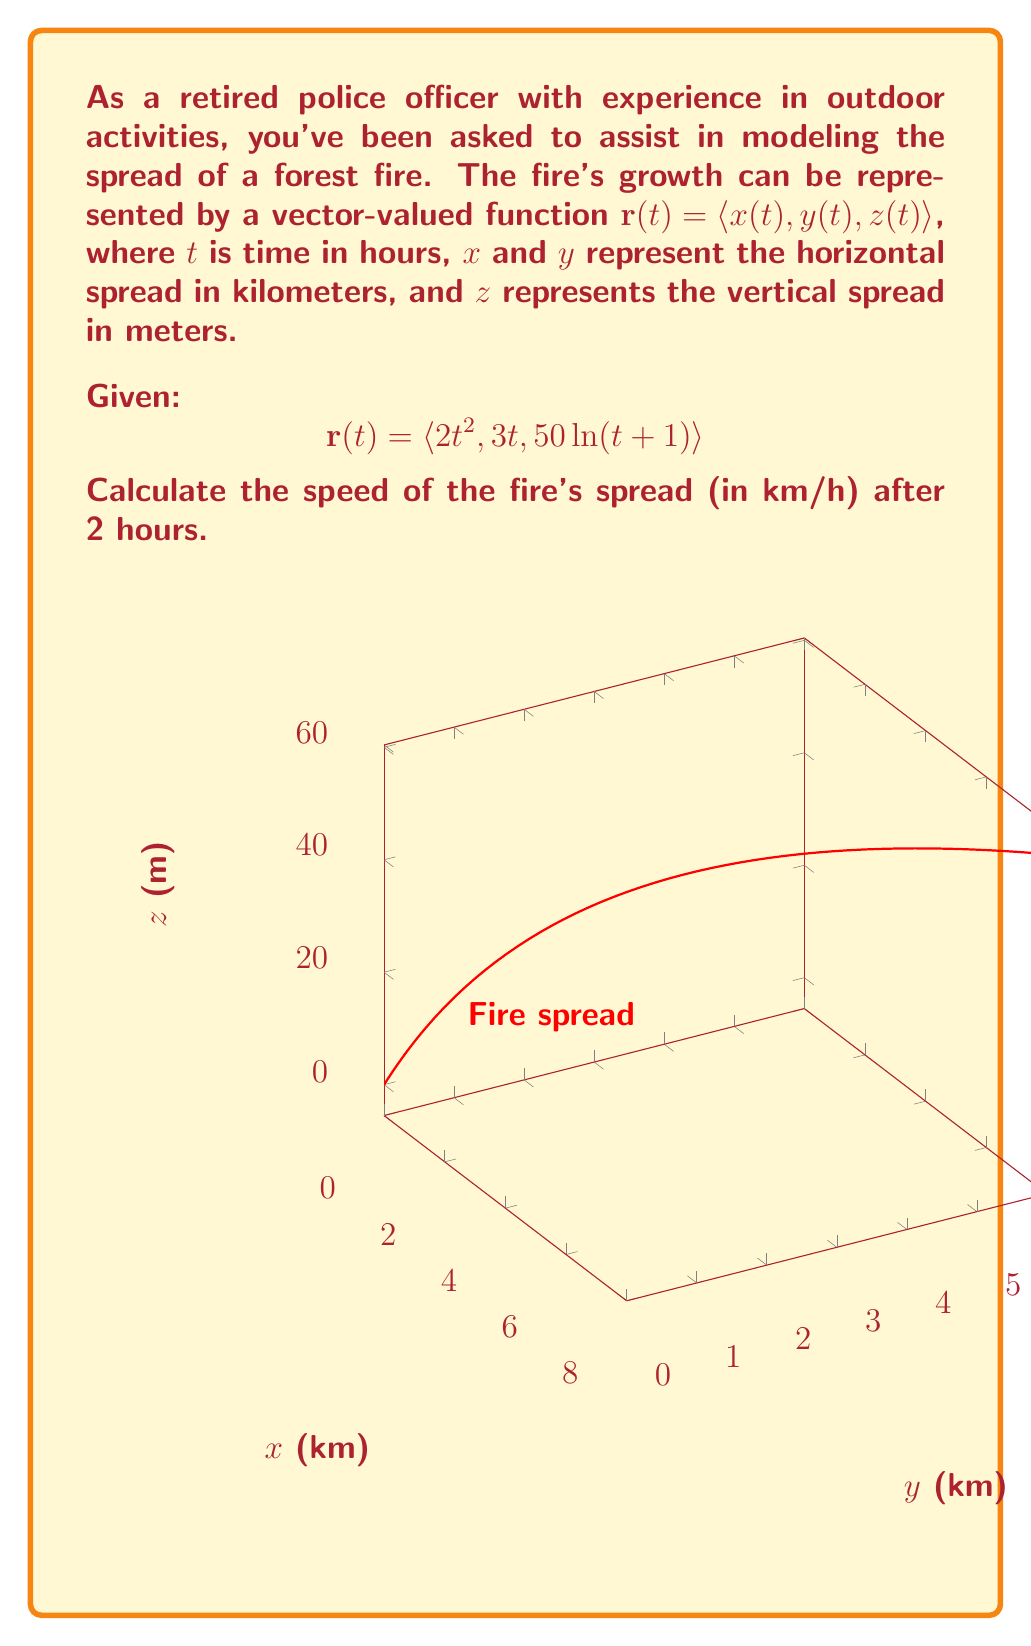Provide a solution to this math problem. To solve this problem, we'll follow these steps:

1) The speed of the fire's spread is given by the magnitude of the velocity vector. The velocity vector is the derivative of the position vector $\mathbf{r}(t)$ with respect to time.

2) Let's find the velocity vector $\mathbf{v}(t)$ by differentiating $\mathbf{r}(t)$:

   $$\mathbf{v}(t) = \frac{d}{dt}\mathbf{r}(t) = \langle \frac{d}{dt}(2t^2), \frac{d}{dt}(3t), \frac{d}{dt}(50\ln(t+1)) \rangle$$

3) Applying the differentiation rules:

   $$\mathbf{v}(t) = \langle 4t, 3, \frac{50}{t+1} \rangle$$

4) The speed is the magnitude of the velocity vector. We can calculate this using the formula:

   $$\text{speed} = \|\mathbf{v}(t)\| = \sqrt{(4t)^2 + 3^2 + (\frac{50}{t+1})^2}$$

5) We need to calculate the speed at $t = 2$ hours:

   $$\text{speed} = \sqrt{(4(2))^2 + 3^2 + (\frac{50}{2+1})^2}$$

6) Simplifying:

   $$\text{speed} = \sqrt{64 + 9 + (\frac{50}{3})^2} = \sqrt{64 + 9 + \frac{2500}{9}}$$

7) Calculating:

   $$\text{speed} = \sqrt{73 + \frac{2500}{9}} \approx 18.16 \text{ km/h}$$
Answer: $18.16 \text{ km/h}$ 